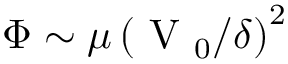Convert formula to latex. <formula><loc_0><loc_0><loc_500><loc_500>\Phi \sim \mu \left ( { V _ { 0 } } / { \delta } \right ) ^ { 2 }</formula> 